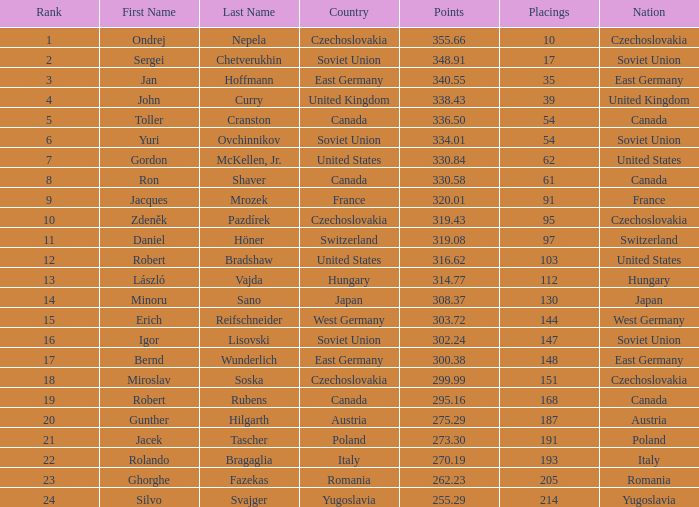How many Placings have Points smaller than 330.84, and a Name of silvo svajger? 1.0. 